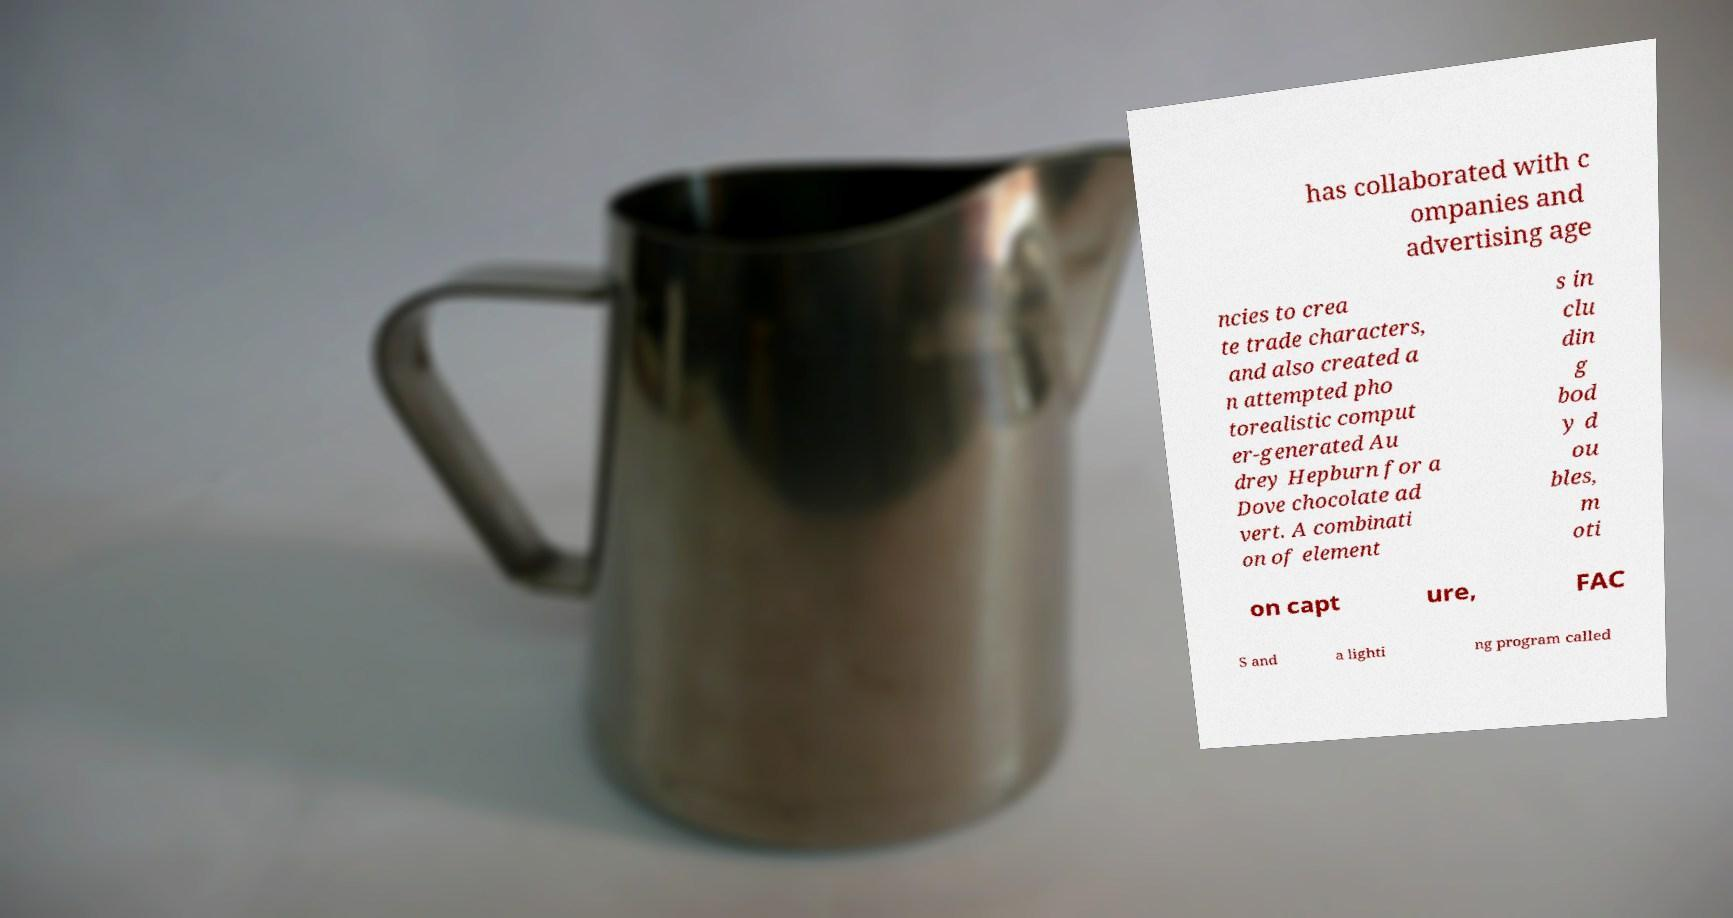Please identify and transcribe the text found in this image. has collaborated with c ompanies and advertising age ncies to crea te trade characters, and also created a n attempted pho torealistic comput er-generated Au drey Hepburn for a Dove chocolate ad vert. A combinati on of element s in clu din g bod y d ou bles, m oti on capt ure, FAC S and a lighti ng program called 